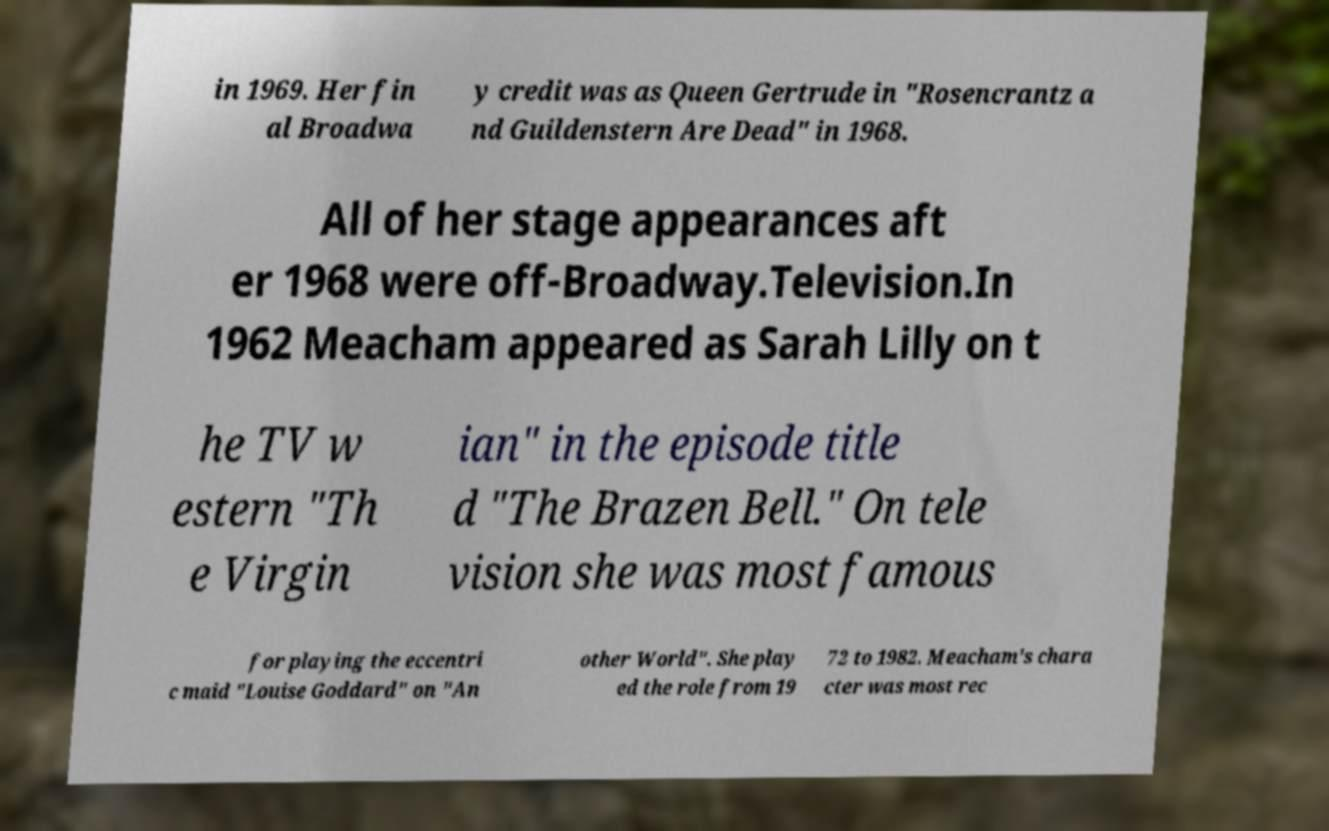Can you accurately transcribe the text from the provided image for me? in 1969. Her fin al Broadwa y credit was as Queen Gertrude in "Rosencrantz a nd Guildenstern Are Dead" in 1968. All of her stage appearances aft er 1968 were off-Broadway.Television.In 1962 Meacham appeared as Sarah Lilly on t he TV w estern "Th e Virgin ian" in the episode title d "The Brazen Bell." On tele vision she was most famous for playing the eccentri c maid "Louise Goddard" on "An other World". She play ed the role from 19 72 to 1982. Meacham's chara cter was most rec 